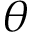<formula> <loc_0><loc_0><loc_500><loc_500>\theta</formula> 